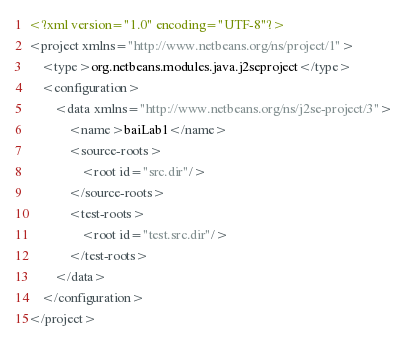Convert code to text. <code><loc_0><loc_0><loc_500><loc_500><_XML_><?xml version="1.0" encoding="UTF-8"?>
<project xmlns="http://www.netbeans.org/ns/project/1">
    <type>org.netbeans.modules.java.j2seproject</type>
    <configuration>
        <data xmlns="http://www.netbeans.org/ns/j2se-project/3">
            <name>baiLab1</name>
            <source-roots>
                <root id="src.dir"/>
            </source-roots>
            <test-roots>
                <root id="test.src.dir"/>
            </test-roots>
        </data>
    </configuration>
</project>
</code> 